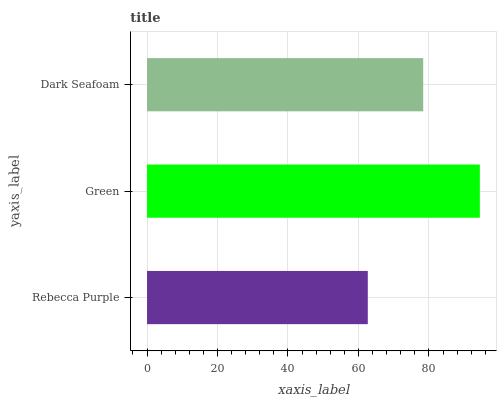Is Rebecca Purple the minimum?
Answer yes or no. Yes. Is Green the maximum?
Answer yes or no. Yes. Is Dark Seafoam the minimum?
Answer yes or no. No. Is Dark Seafoam the maximum?
Answer yes or no. No. Is Green greater than Dark Seafoam?
Answer yes or no. Yes. Is Dark Seafoam less than Green?
Answer yes or no. Yes. Is Dark Seafoam greater than Green?
Answer yes or no. No. Is Green less than Dark Seafoam?
Answer yes or no. No. Is Dark Seafoam the high median?
Answer yes or no. Yes. Is Dark Seafoam the low median?
Answer yes or no. Yes. Is Green the high median?
Answer yes or no. No. Is Green the low median?
Answer yes or no. No. 